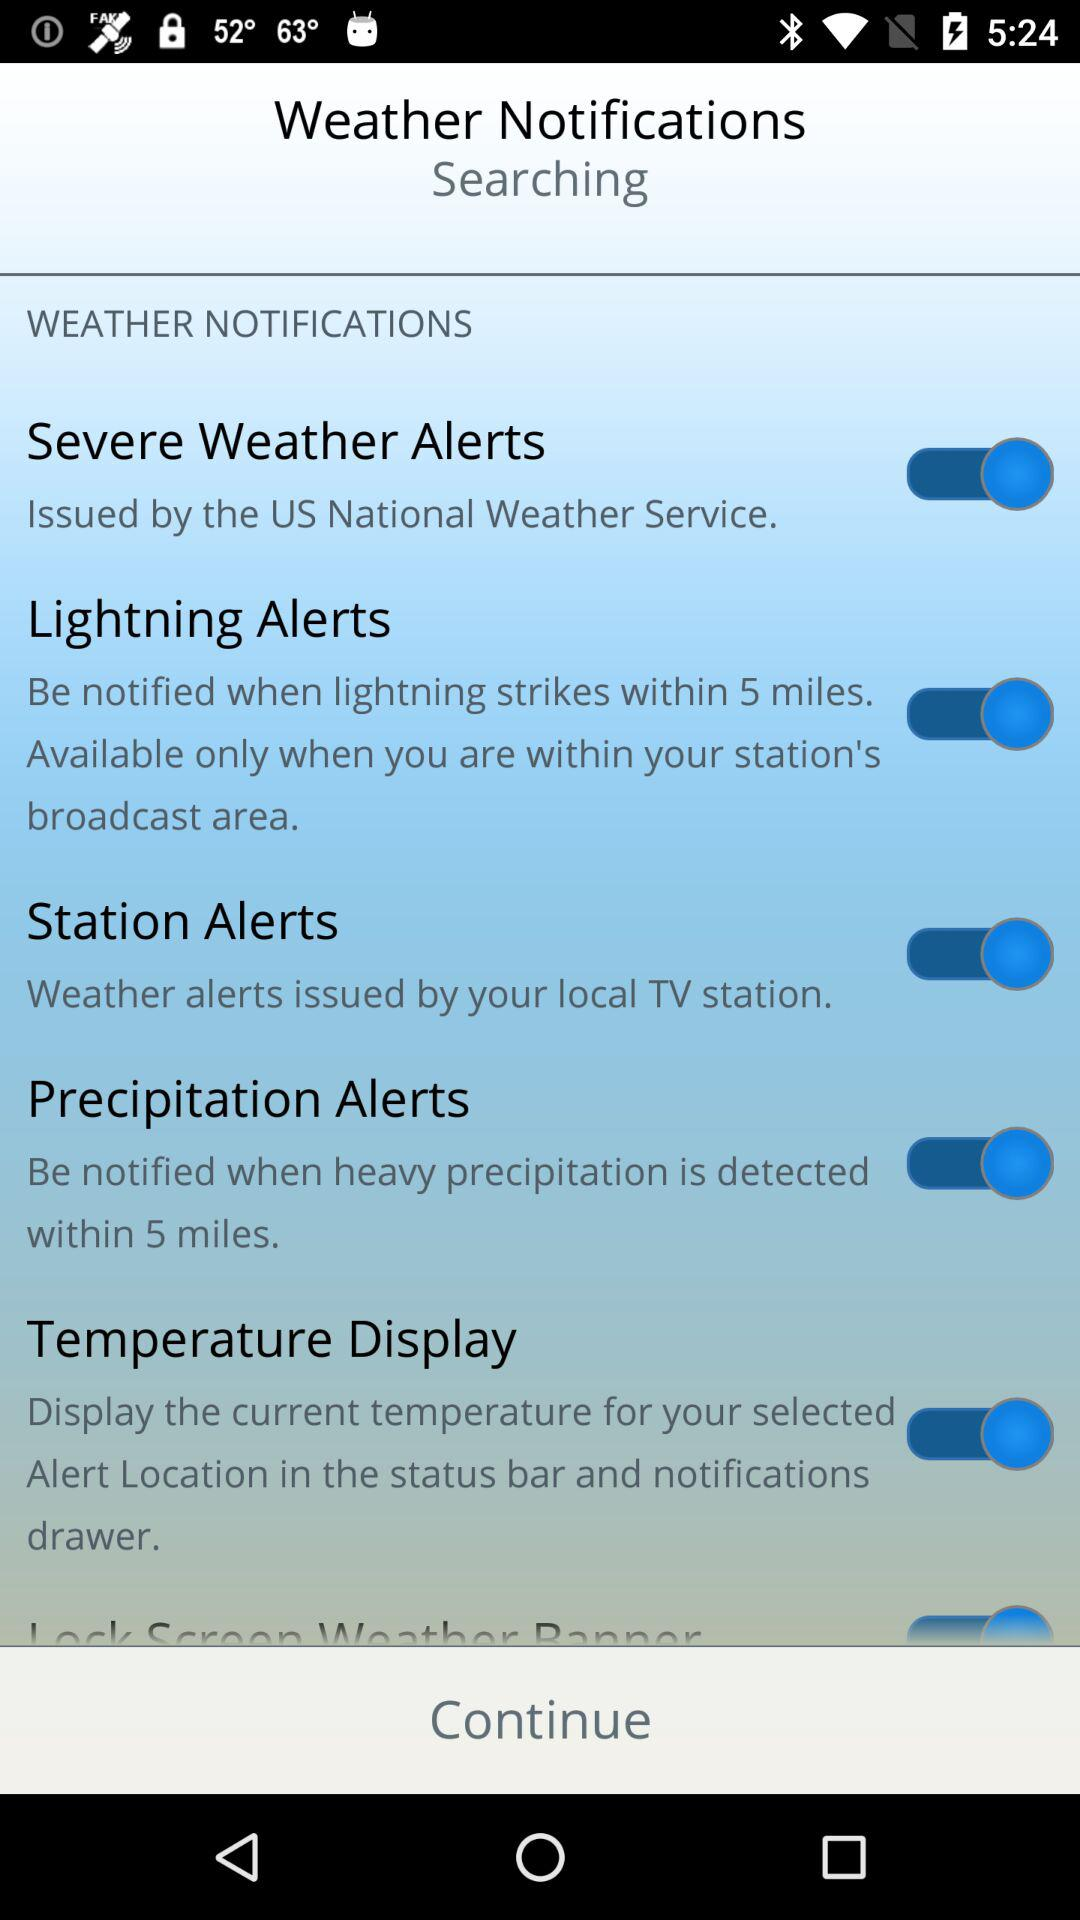What is the status of "Lightning Alerts"? The status is "on". 